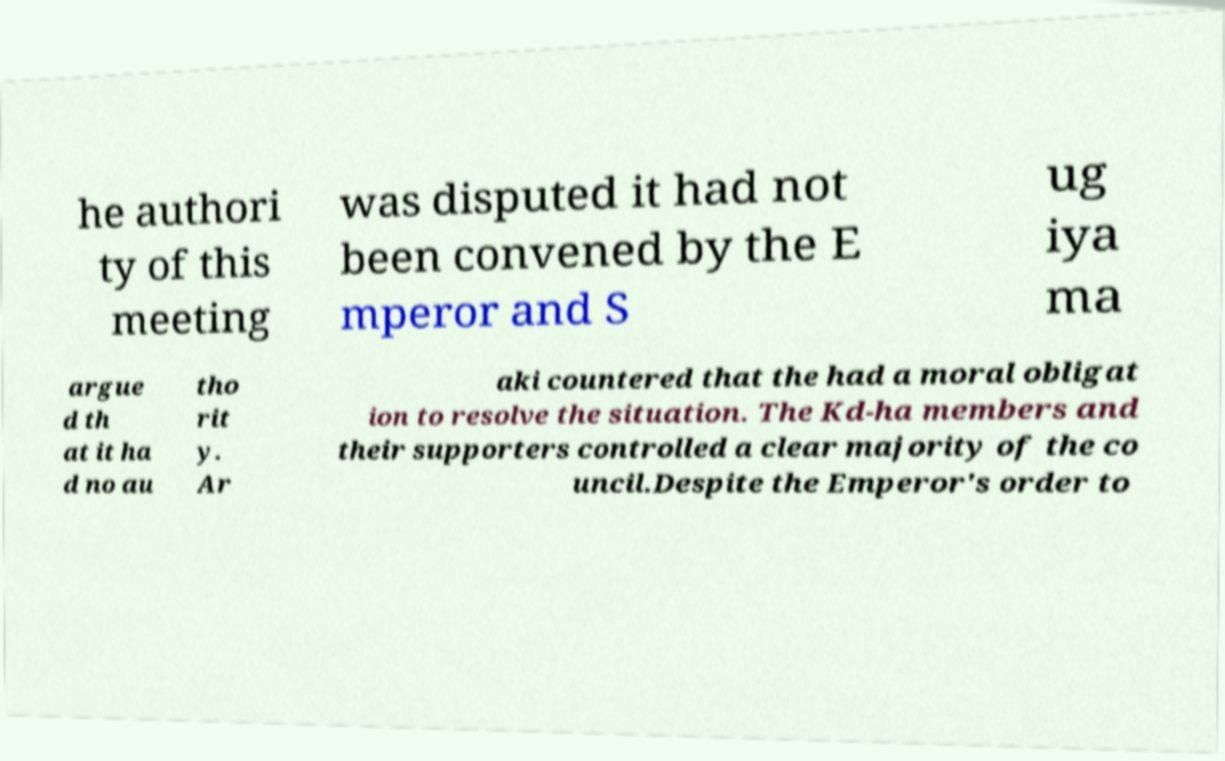Please identify and transcribe the text found in this image. he authori ty of this meeting was disputed it had not been convened by the E mperor and S ug iya ma argue d th at it ha d no au tho rit y. Ar aki countered that the had a moral obligat ion to resolve the situation. The Kd-ha members and their supporters controlled a clear majority of the co uncil.Despite the Emperor's order to 